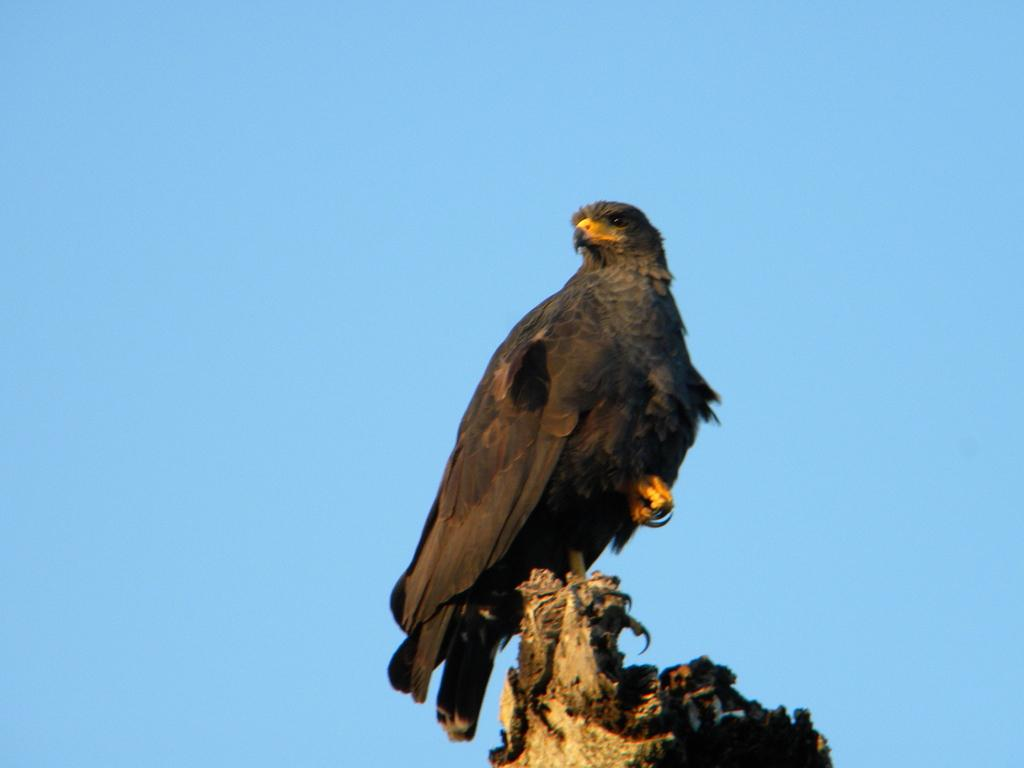What is the main object in the center of the image? There is a piece of wood in the center of the image. What is on top of the wood? There is a bird on the wood. What color is the bird? The bird is black in color. What can be seen in the background of the image? There is a sky visible in the background of the image. What flavor of ice cream does the bird on the wood enjoy? There is no ice cream present in the image, so it is not possible to determine the bird's flavor preference. 